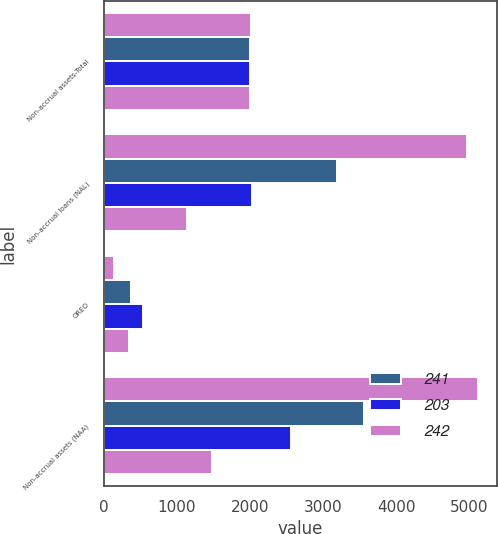<chart> <loc_0><loc_0><loc_500><loc_500><stacked_bar_chart><ecel><fcel>Non-accrual assets-Total<fcel>Non-accrual loans (NAL)<fcel>OREO<fcel>Non-accrual assets (NAA)<nl><fcel>nan<fcel>2009<fcel>4968<fcel>148<fcel>5116<nl><fcel>241<fcel>2008<fcel>3193<fcel>371<fcel>3564<nl><fcel>203<fcel>2007<fcel>2027<fcel>541<fcel>2568<nl><fcel>242<fcel>2006<fcel>1141<fcel>342<fcel>1483<nl></chart> 